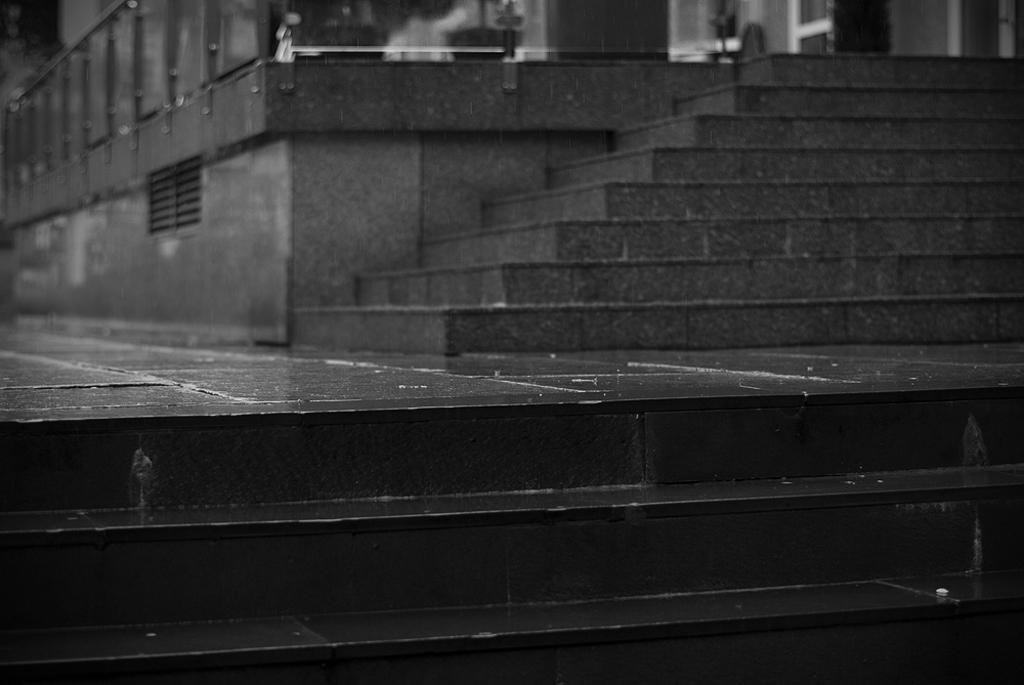What is the color scheme of the image? The image is black and white. What architectural feature can be seen in the image? There are stairs in the image. What part of the floor can be seen in the image? The floor is visible in the image. What safety feature is present in the image? There is a railing in the image. What can be seen through the window in the image? The image does not provide enough detail to determine what can be seen through the window. How many doors are visible in the image? There are doors in the image. How many lizards are crawling on the cloth in the image? There are no lizards or cloth present in the image. What type of spot is visible on the floor in the image? The image does not provide enough detail to determine if there is a spot on the floor. 